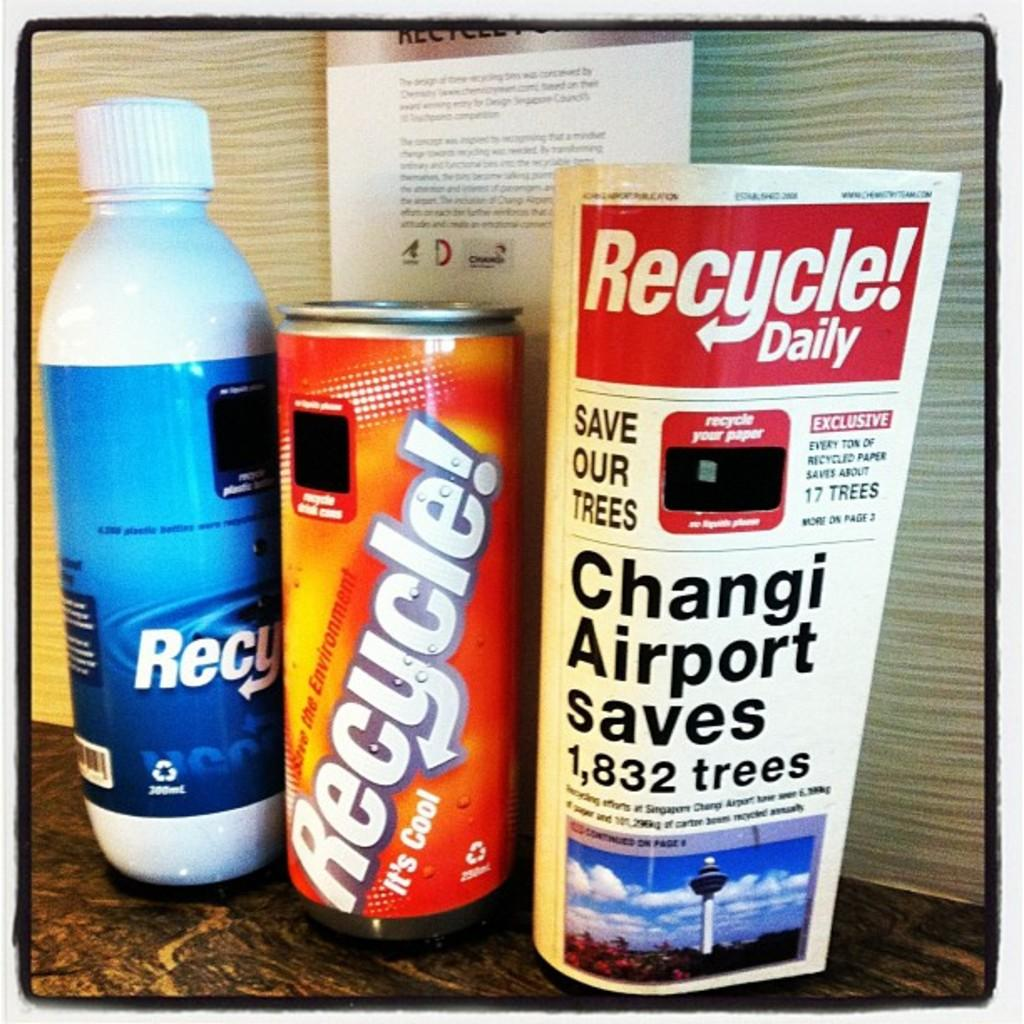Provide a one-sentence caption for the provided image. Three different bottles of of recycling materials and a paper with the word recycle in bold. 